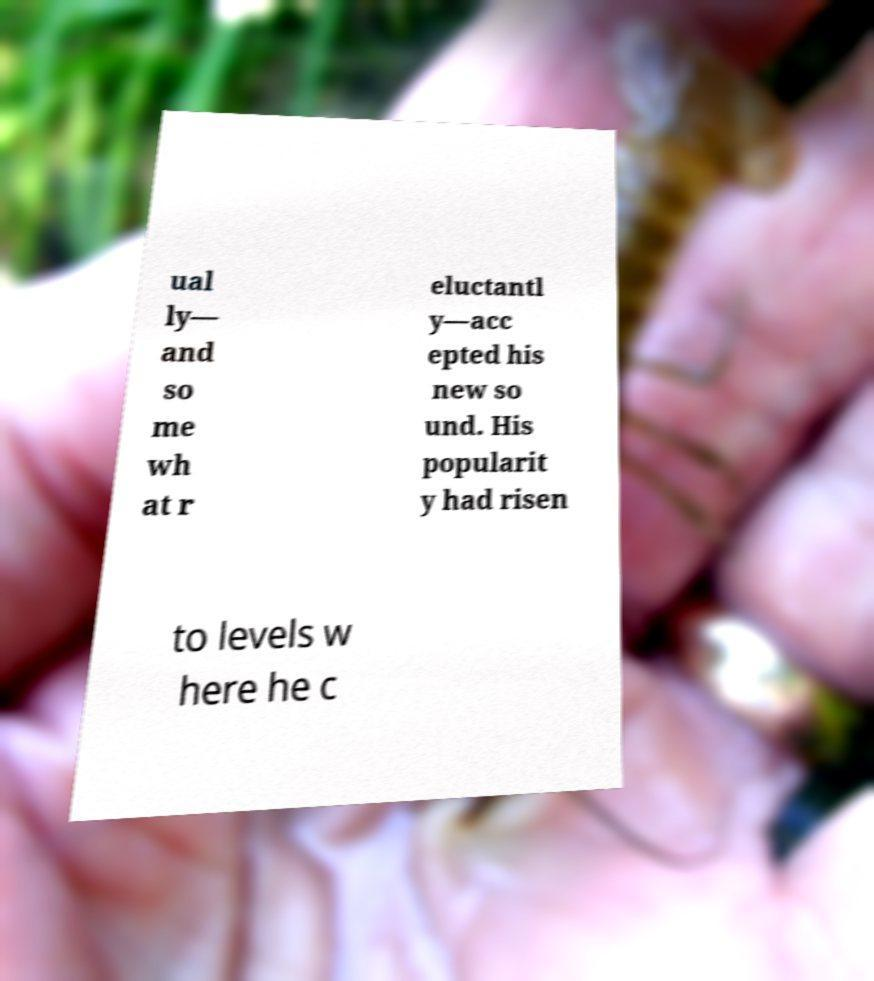Can you accurately transcribe the text from the provided image for me? ual ly— and so me wh at r eluctantl y—acc epted his new so und. His popularit y had risen to levels w here he c 